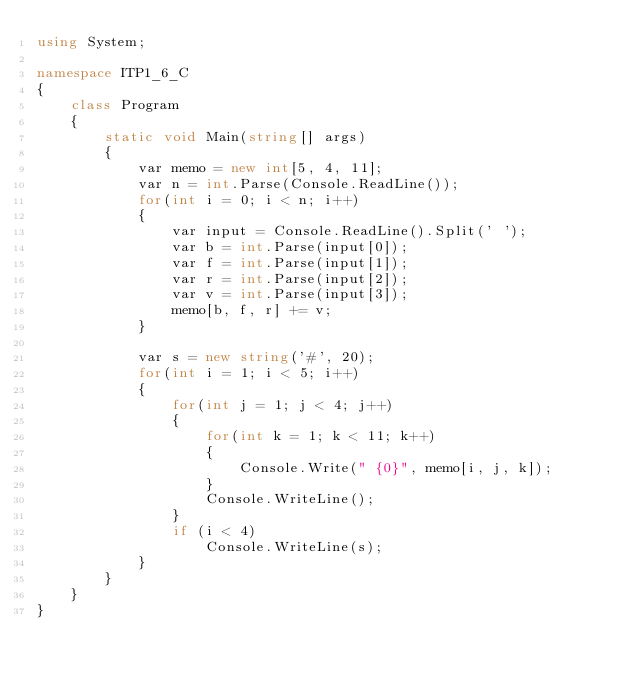<code> <loc_0><loc_0><loc_500><loc_500><_C#_>using System;

namespace ITP1_6_C
{
    class Program
    {
        static void Main(string[] args)
        {
            var memo = new int[5, 4, 11];
            var n = int.Parse(Console.ReadLine());
            for(int i = 0; i < n; i++)
            {
                var input = Console.ReadLine().Split(' ');
                var b = int.Parse(input[0]);
                var f = int.Parse(input[1]);
                var r = int.Parse(input[2]);
                var v = int.Parse(input[3]);
                memo[b, f, r] += v;
            }

            var s = new string('#', 20);
            for(int i = 1; i < 5; i++)
            {
                for(int j = 1; j < 4; j++)
                {
                    for(int k = 1; k < 11; k++)
                    {
                        Console.Write(" {0}", memo[i, j, k]);
                    }
                    Console.WriteLine();
                }
                if (i < 4)
                    Console.WriteLine(s);
            }
        }
    }
}</code> 